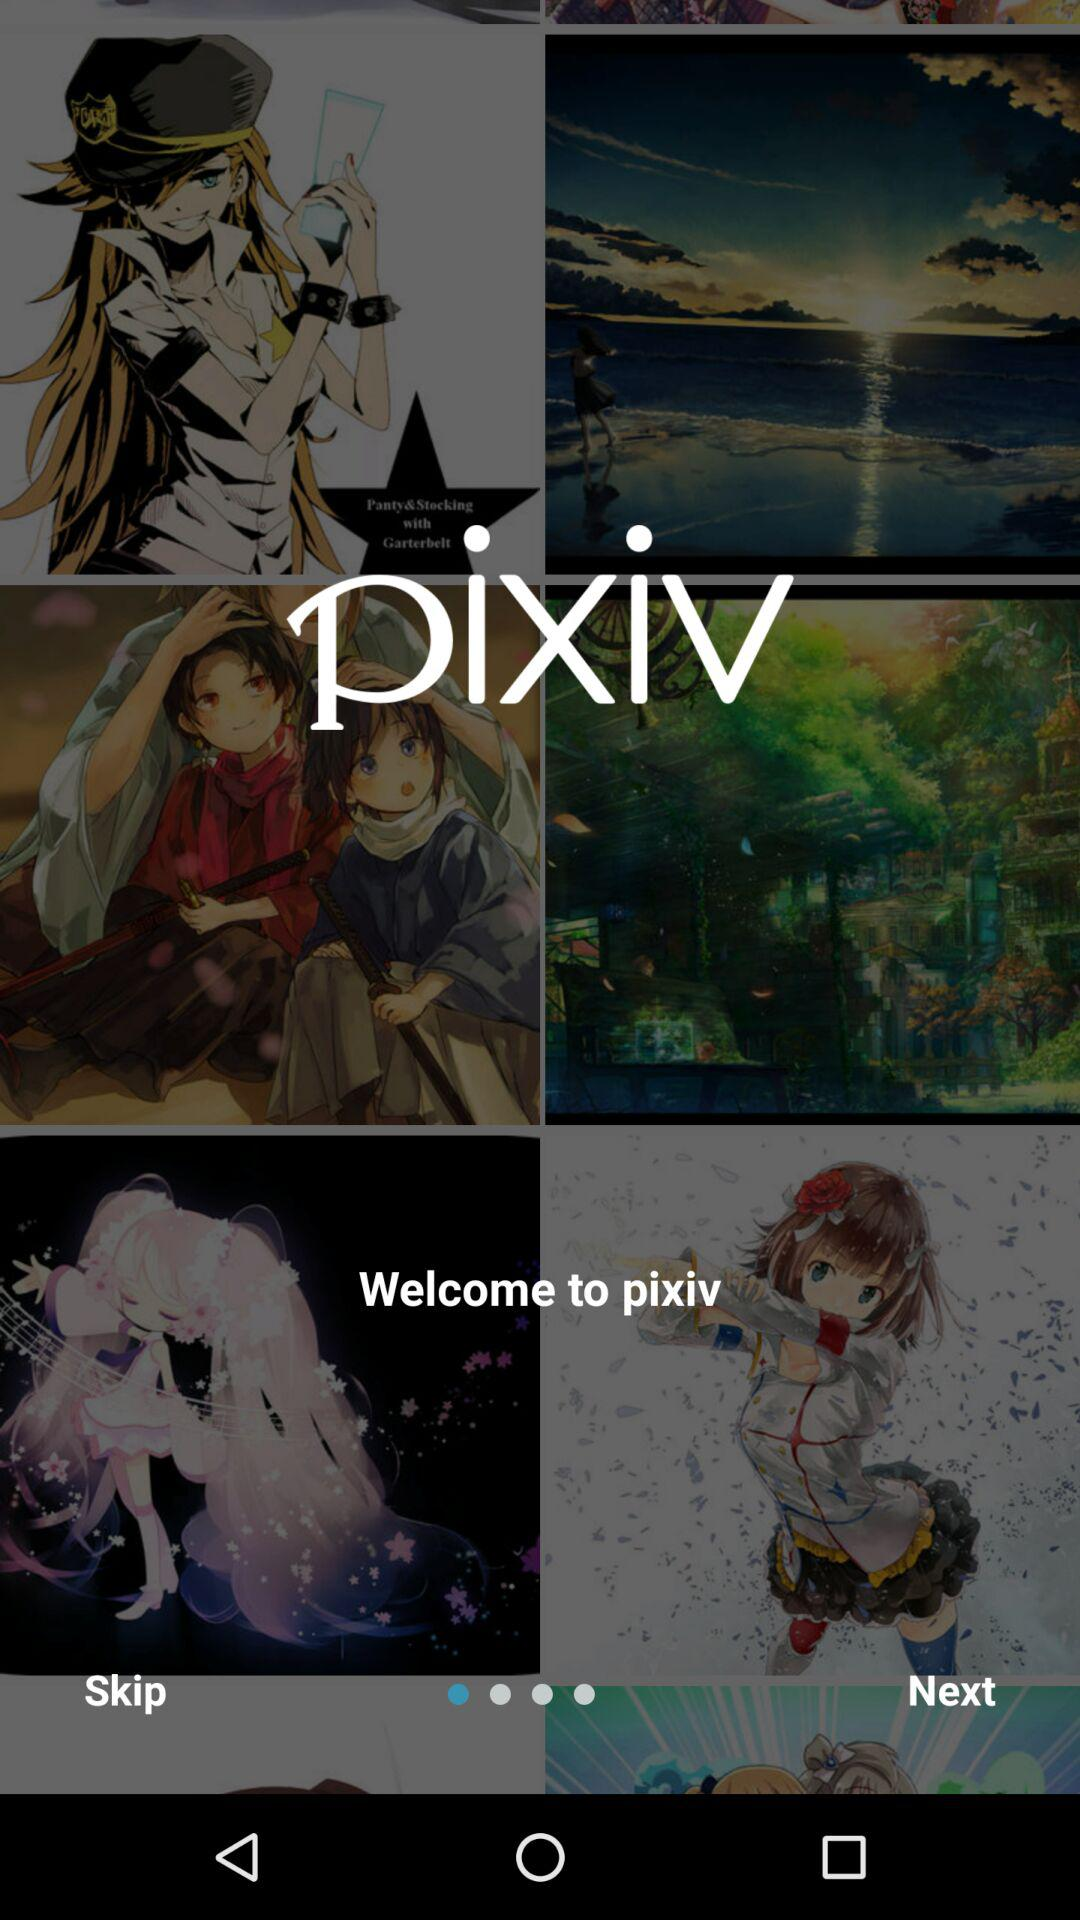What is the application name? The application name is "pixiv". 